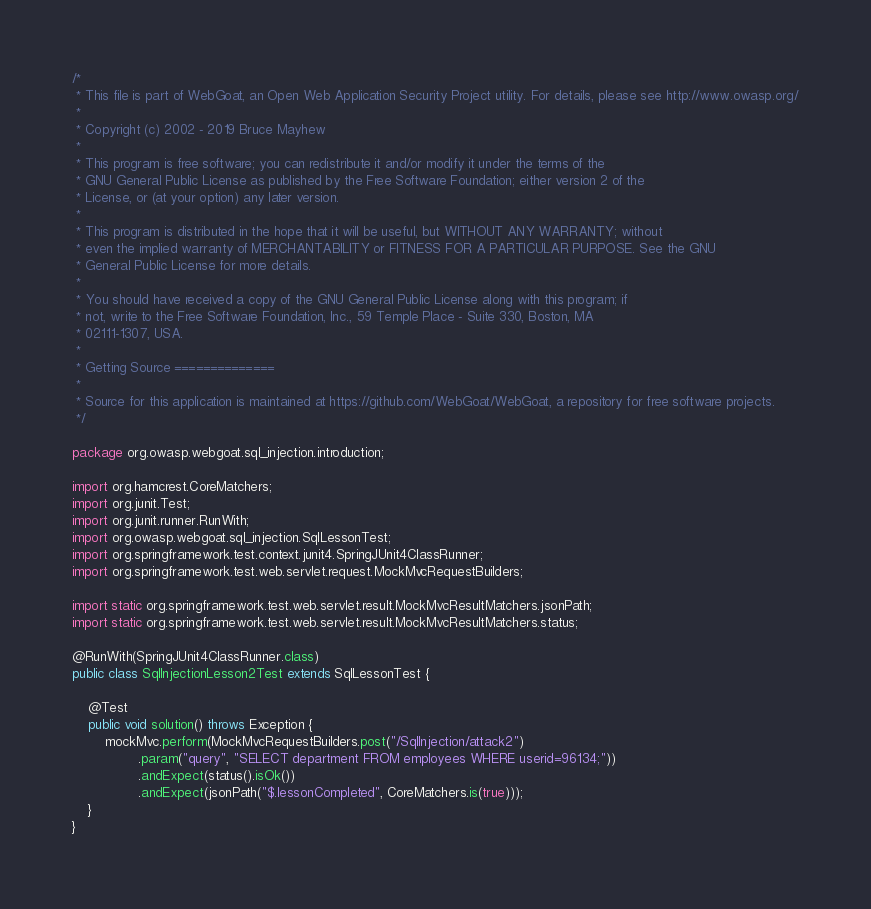<code> <loc_0><loc_0><loc_500><loc_500><_Java_>/*
 * This file is part of WebGoat, an Open Web Application Security Project utility. For details, please see http://www.owasp.org/
 *
 * Copyright (c) 2002 - 2019 Bruce Mayhew
 *
 * This program is free software; you can redistribute it and/or modify it under the terms of the
 * GNU General Public License as published by the Free Software Foundation; either version 2 of the
 * License, or (at your option) any later version.
 *
 * This program is distributed in the hope that it will be useful, but WITHOUT ANY WARRANTY; without
 * even the implied warranty of MERCHANTABILITY or FITNESS FOR A PARTICULAR PURPOSE. See the GNU
 * General Public License for more details.
 *
 * You should have received a copy of the GNU General Public License along with this program; if
 * not, write to the Free Software Foundation, Inc., 59 Temple Place - Suite 330, Boston, MA
 * 02111-1307, USA.
 *
 * Getting Source ==============
 *
 * Source for this application is maintained at https://github.com/WebGoat/WebGoat, a repository for free software projects.
 */

package org.owasp.webgoat.sql_injection.introduction;

import org.hamcrest.CoreMatchers;
import org.junit.Test;
import org.junit.runner.RunWith;
import org.owasp.webgoat.sql_injection.SqlLessonTest;
import org.springframework.test.context.junit4.SpringJUnit4ClassRunner;
import org.springframework.test.web.servlet.request.MockMvcRequestBuilders;

import static org.springframework.test.web.servlet.result.MockMvcResultMatchers.jsonPath;
import static org.springframework.test.web.servlet.result.MockMvcResultMatchers.status;

@RunWith(SpringJUnit4ClassRunner.class)
public class SqlInjectionLesson2Test extends SqlLessonTest {

    @Test
    public void solution() throws Exception {
        mockMvc.perform(MockMvcRequestBuilders.post("/SqlInjection/attack2")
                .param("query", "SELECT department FROM employees WHERE userid=96134;"))
                .andExpect(status().isOk())
                .andExpect(jsonPath("$.lessonCompleted", CoreMatchers.is(true)));
    }
}</code> 